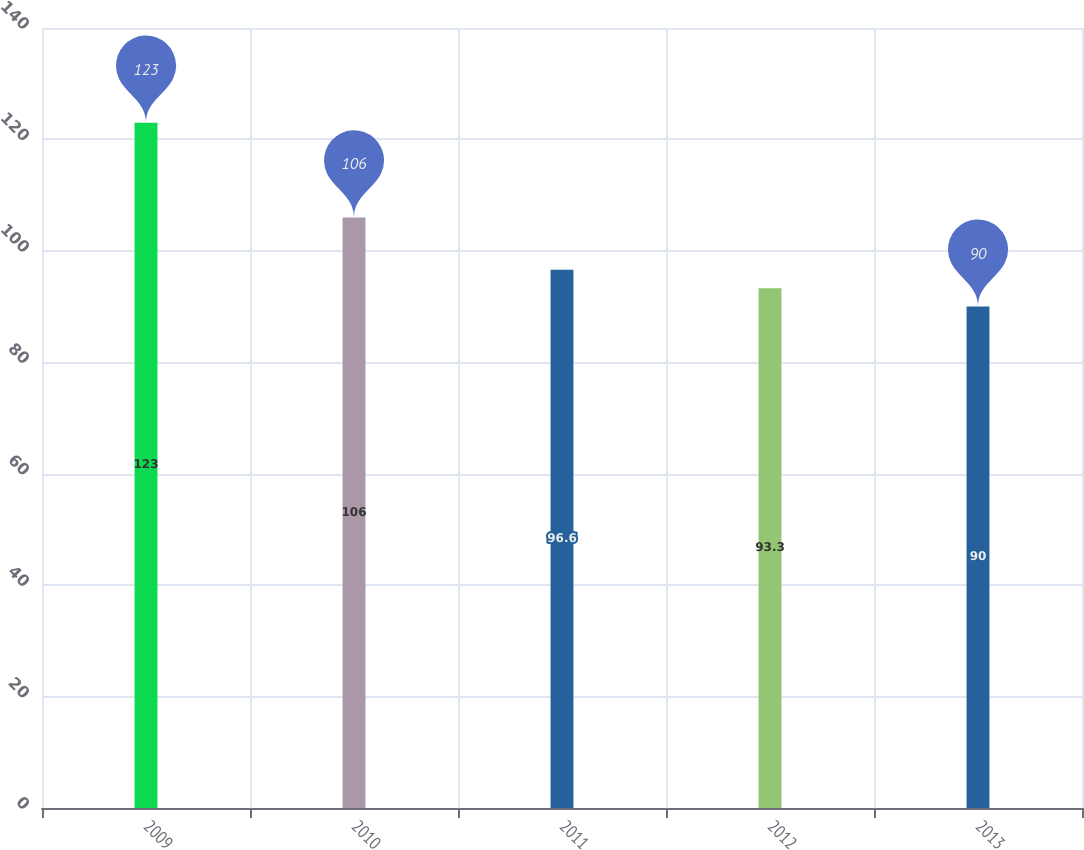<chart> <loc_0><loc_0><loc_500><loc_500><bar_chart><fcel>2009<fcel>2010<fcel>2011<fcel>2012<fcel>2013<nl><fcel>123<fcel>106<fcel>96.6<fcel>93.3<fcel>90<nl></chart> 